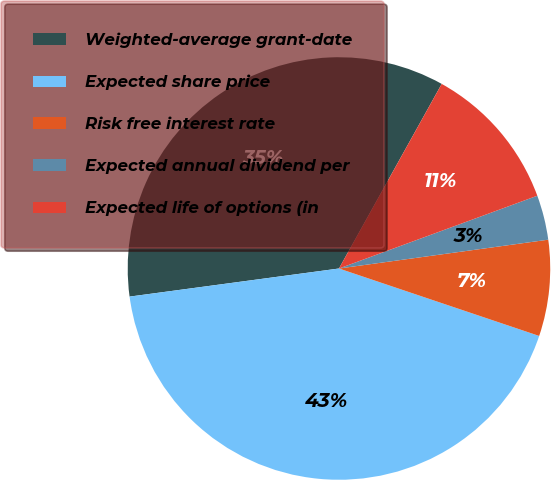Convert chart to OTSL. <chart><loc_0><loc_0><loc_500><loc_500><pie_chart><fcel>Weighted-average grant-date<fcel>Expected share price<fcel>Risk free interest rate<fcel>Expected annual dividend per<fcel>Expected life of options (in<nl><fcel>35.21%<fcel>42.71%<fcel>7.35%<fcel>3.42%<fcel>11.32%<nl></chart> 